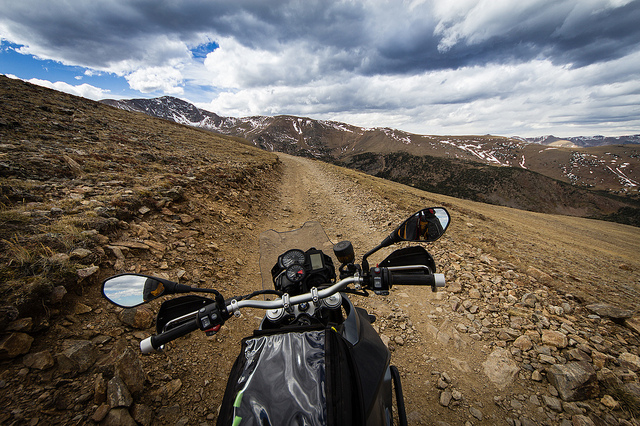Is it cloudy?
Answer the question using a single word or phrase. Yes Is the bike parked in the middle of nowhere? Yes Are those mountains in the distance? Yes 